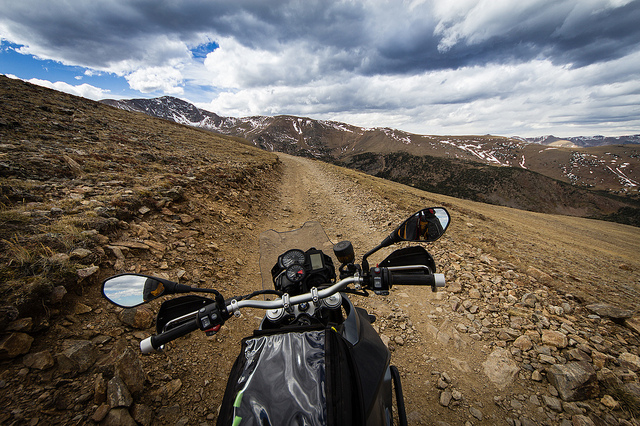Is it cloudy?
Answer the question using a single word or phrase. Yes Is the bike parked in the middle of nowhere? Yes Are those mountains in the distance? Yes 